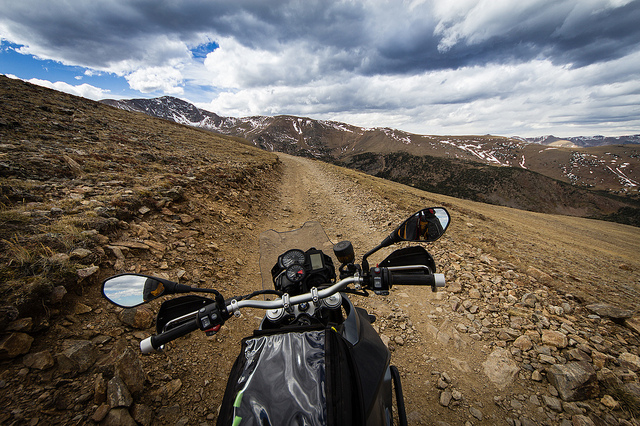Is it cloudy?
Answer the question using a single word or phrase. Yes Is the bike parked in the middle of nowhere? Yes Are those mountains in the distance? Yes 